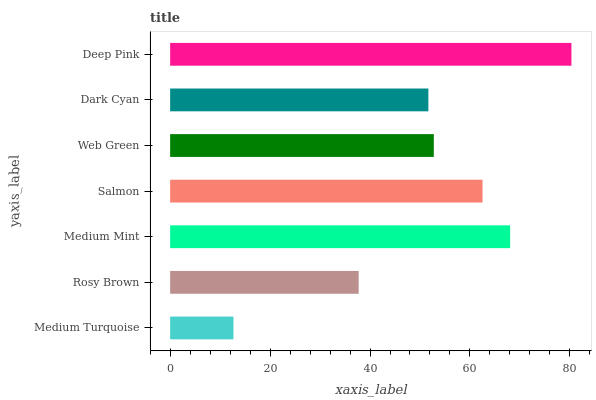Is Medium Turquoise the minimum?
Answer yes or no. Yes. Is Deep Pink the maximum?
Answer yes or no. Yes. Is Rosy Brown the minimum?
Answer yes or no. No. Is Rosy Brown the maximum?
Answer yes or no. No. Is Rosy Brown greater than Medium Turquoise?
Answer yes or no. Yes. Is Medium Turquoise less than Rosy Brown?
Answer yes or no. Yes. Is Medium Turquoise greater than Rosy Brown?
Answer yes or no. No. Is Rosy Brown less than Medium Turquoise?
Answer yes or no. No. Is Web Green the high median?
Answer yes or no. Yes. Is Web Green the low median?
Answer yes or no. Yes. Is Medium Mint the high median?
Answer yes or no. No. Is Salmon the low median?
Answer yes or no. No. 